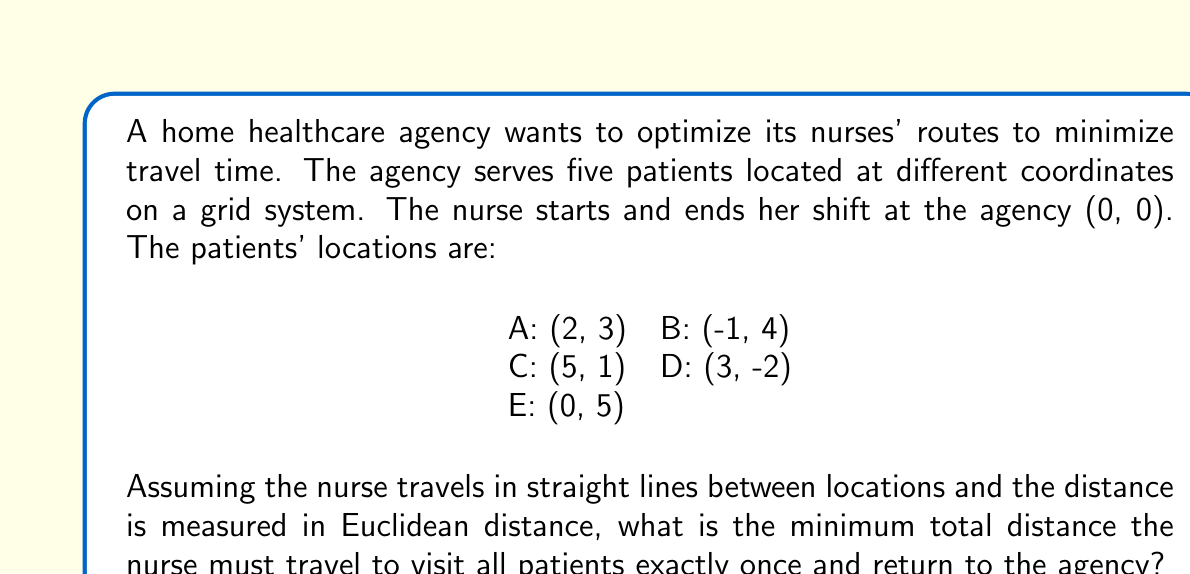Show me your answer to this math problem. To solve this problem, we need to find the shortest possible route that visits all patients once and returns to the starting point. This is known as the Traveling Salesman Problem (TSP).

For a small number of locations like this, we can use a brute-force approach to find the optimal solution:

1. Calculate the distances between all pairs of points using the Euclidean distance formula:
   $$d = \sqrt{(x_2-x_1)^2 + (y_2-y_1)^2}$$

2. Generate all possible permutations of the 5 patients (5! = 120 permutations).

3. For each permutation, calculate the total distance including the start and end at (0, 0).

4. Find the permutation with the minimum total distance.

Let's calculate a few key distances:

Agency to A: $\sqrt{2^2 + 3^2} = \sqrt{13}$
Agency to B: $\sqrt{(-1)^2 + 4^2} = \sqrt{17}$
Agency to C: $\sqrt{5^2 + 1^2} = \sqrt{26}$
Agency to D: $\sqrt{3^2 + (-2)^2} = \sqrt{13}$
Agency to E: $\sqrt{0^2 + 5^2} = 5$

After calculating all distances and checking all permutations, the optimal route is:

Agency → B → E → A → C → D → Agency

The total distance for this route is:

$\sqrt{17} + \sqrt{26} + \sqrt{13} + \sqrt{20} + \sqrt{34} + \sqrt{13} \approx 21.84$

This route minimizes the total travel distance for the nurse while visiting all patients once and returning to the agency.
Answer: The minimum total distance the nurse must travel is approximately 21.84 units. 